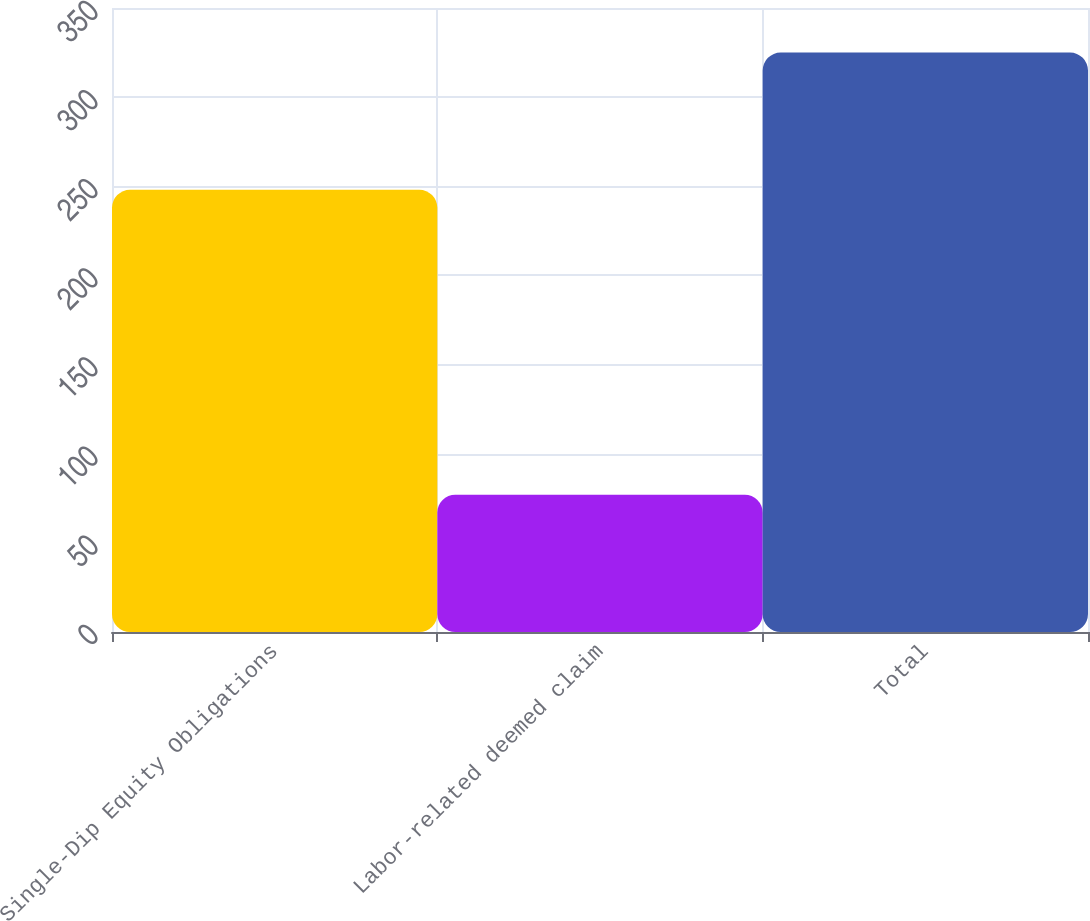Convert chart to OTSL. <chart><loc_0><loc_0><loc_500><loc_500><bar_chart><fcel>Single-Dip Equity Obligations<fcel>Labor-related deemed claim<fcel>Total<nl><fcel>248<fcel>77<fcel>325<nl></chart> 